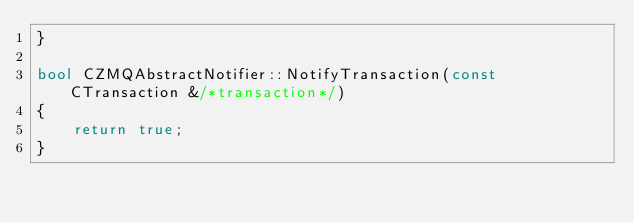<code> <loc_0><loc_0><loc_500><loc_500><_C++_>}

bool CZMQAbstractNotifier::NotifyTransaction(const CTransaction &/*transaction*/)
{
    return true;
}
</code> 